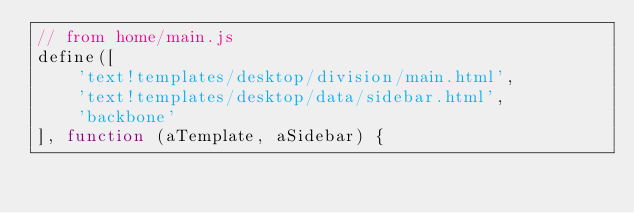<code> <loc_0><loc_0><loc_500><loc_500><_JavaScript_>// from home/main.js
define([
    'text!templates/desktop/division/main.html',
    'text!templates/desktop/data/sidebar.html',
    'backbone'
], function (aTemplate, aSidebar) {</code> 